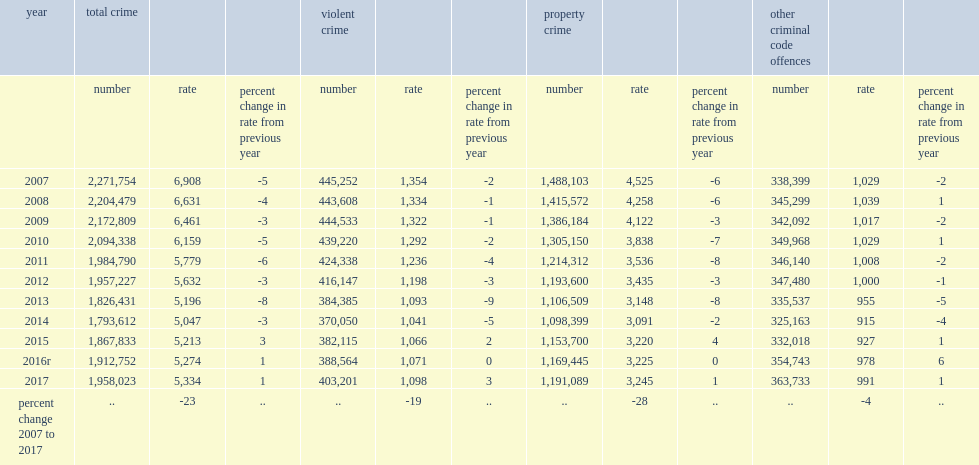What was the percent change in rate from previous year in 2017? 1.0. What was the violent crime rate in canada per 100,000 population in 2017? 1098.0. What was the number of police-reported non-violent criminal code incidents in 2017? 1554822. 